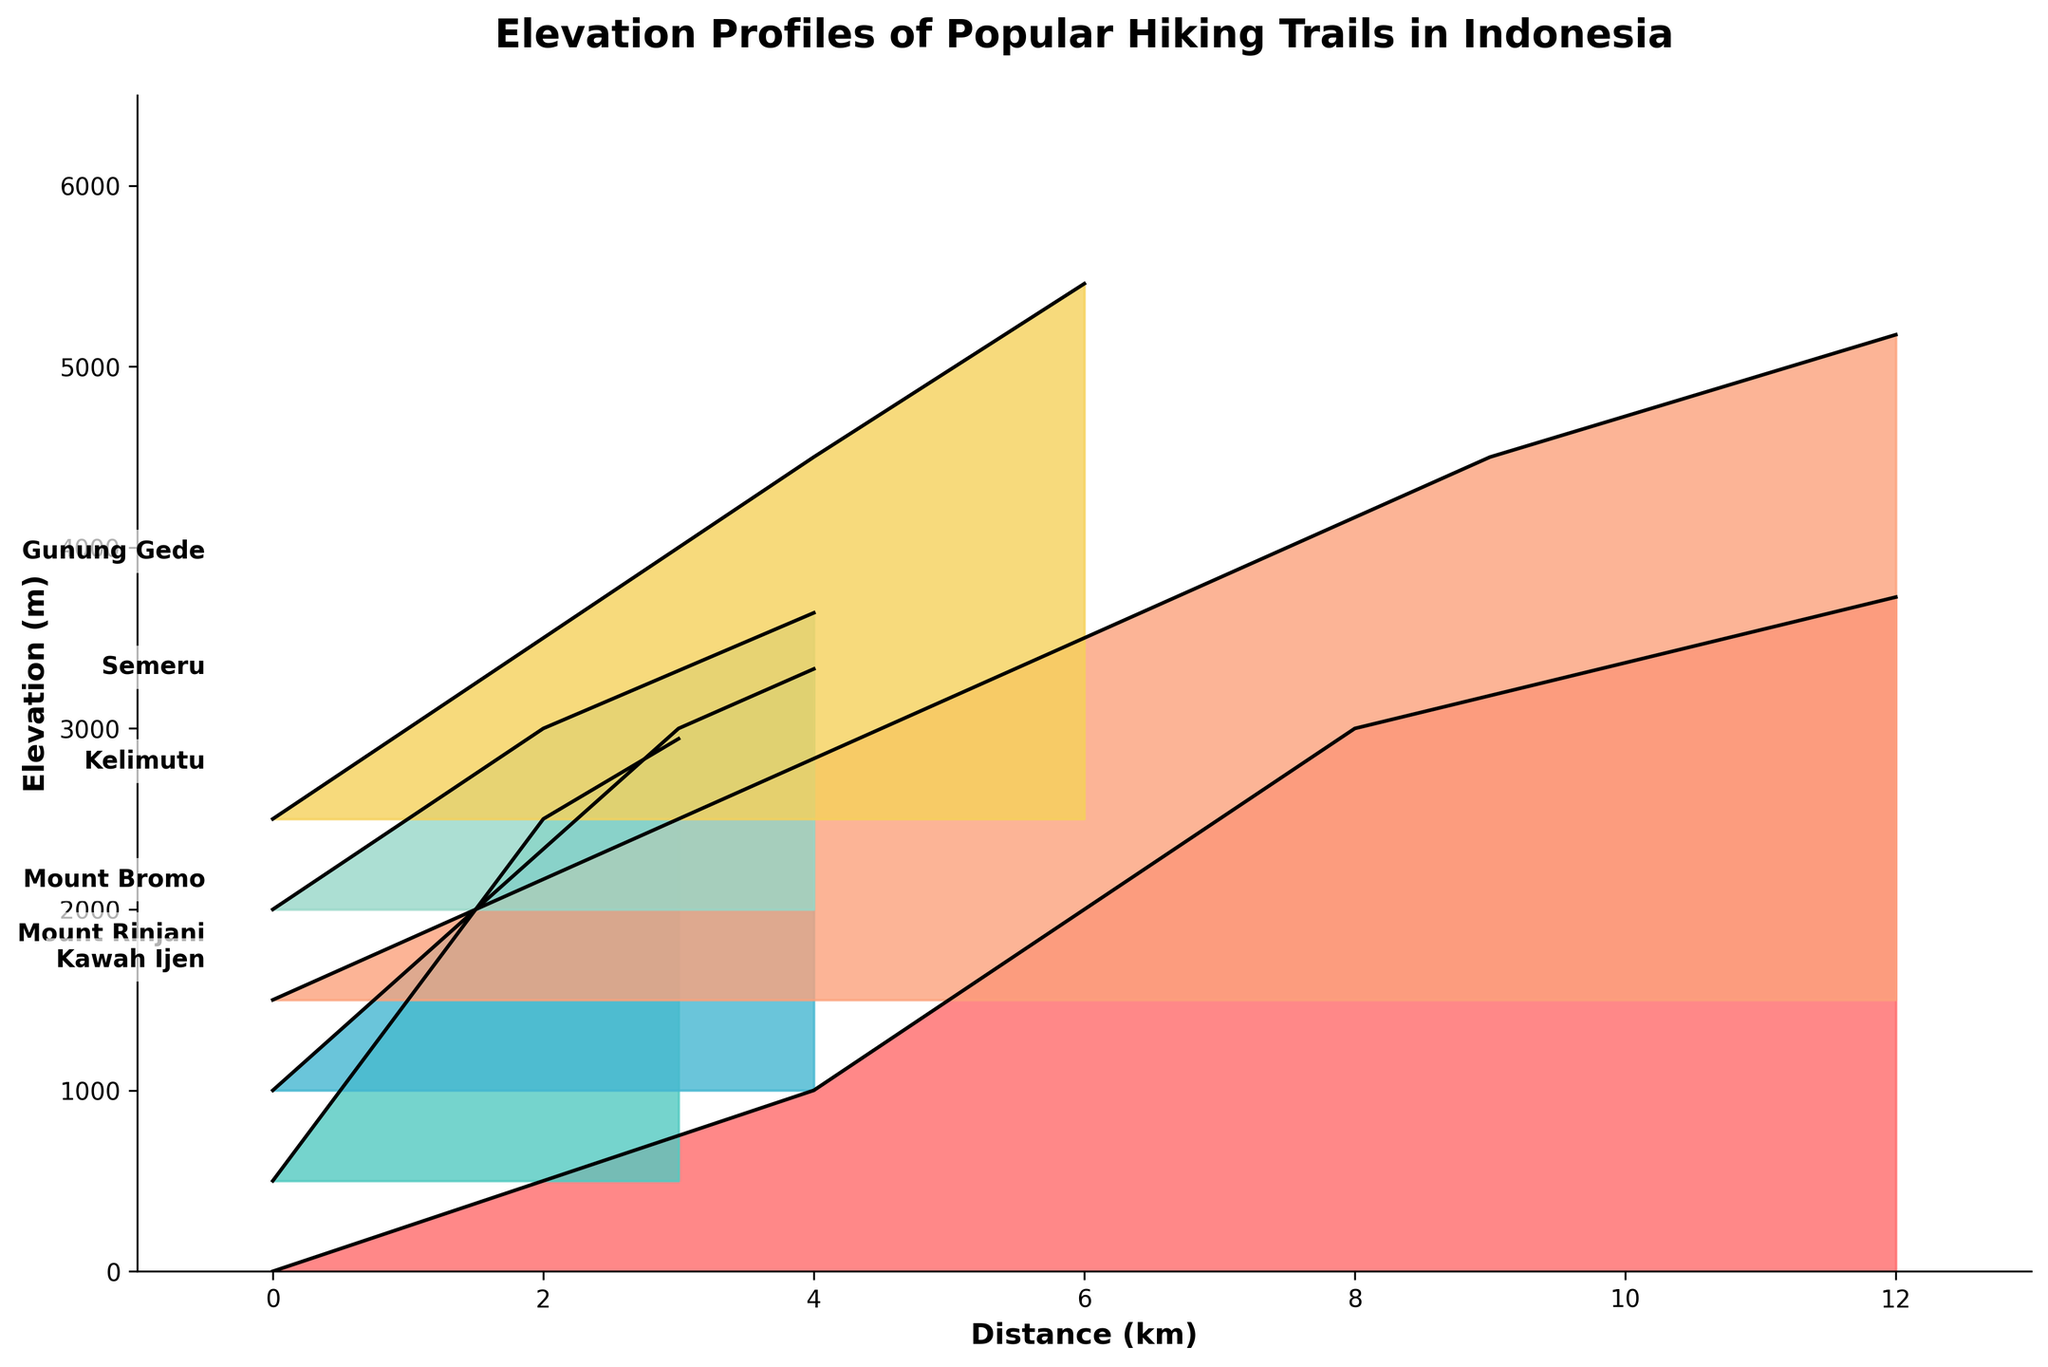What is the title of the figure? The title is found at the top of the figure and typically summarizes the main idea or finding of the visualized data. By looking at the figure, we see that the title is "Elevation Profiles of Popular Hiking Trails in Indonesia."
Answer: Elevation Profiles of Popular Hiking Trails in Indonesia What is the maximum elevation of Mount Rinjani? The maximum elevation for each trail is indicated by the highest point in the elevation profile. For Mount Rinjani, the highest point reaches 3726 meters.
Answer: 3726 meters Which trail has the smallest maximum elevation and what is its value? Looking at the highest points for each trail's profile, Kelimutu has the smallest maximum elevation which reaches 1639 meters.
Answer: Kelimutu, 1639 meters How many kilometers is the trail of Mount Rinjani? By looking at the distance axis (x-axis) and finding the endpoint of Mount Rinjani's elevation profile, the end distance is marked at 12 kilometers.
Answer: 12 kilometers How does the maximum elevation of Mount Bromo compare to that of Gunung Gede? We compare the maximum elevation values by looking at the highest points in their respective profiles. Mount Bromo's highest point is 2329 meters while Gunung Gede reaches 2958 meters, making Gunung Gede higher.
Answer: Gunung Gede is higher Which trail has the longest distance covered and how long is it? By examining the x-axis and identifying the furthest right endpoint for all trails, both Mount Rinjani and Semeru reach the longest distances of 12 kilometers.
Answer: Mount Rinjani and Semeru, 12 kilometers Order the trails based on their maximum elevation in ascending order. By visual inspection of each trail's peak elevation, the order from lowest to highest is Kelimutu (1639m), Mount Bromo (2329m), Kawah Ijen (2443m), Gunung Gede (2958m), Semeru (3676m), and Mount Rinjani (3726m).
Answer: Kelimutu, Mount Bromo, Kawah Ijen, Gunung Gede, Semeru, Mount Rinjani How does the elevation profile of Kawah Ijen compare with that of Gunung Gede in terms of steepness over distance? By comparing the slopes of the elevation paths, we see Kawah Ijen's profile climbs quickly up 2443 meters within 3 kilometers, while Gunung Gede rises gradually over 6 kilometers to 2958 meters, indicating Kawah Ijen is steeper.
Answer: Kawah Ijen is steeper 